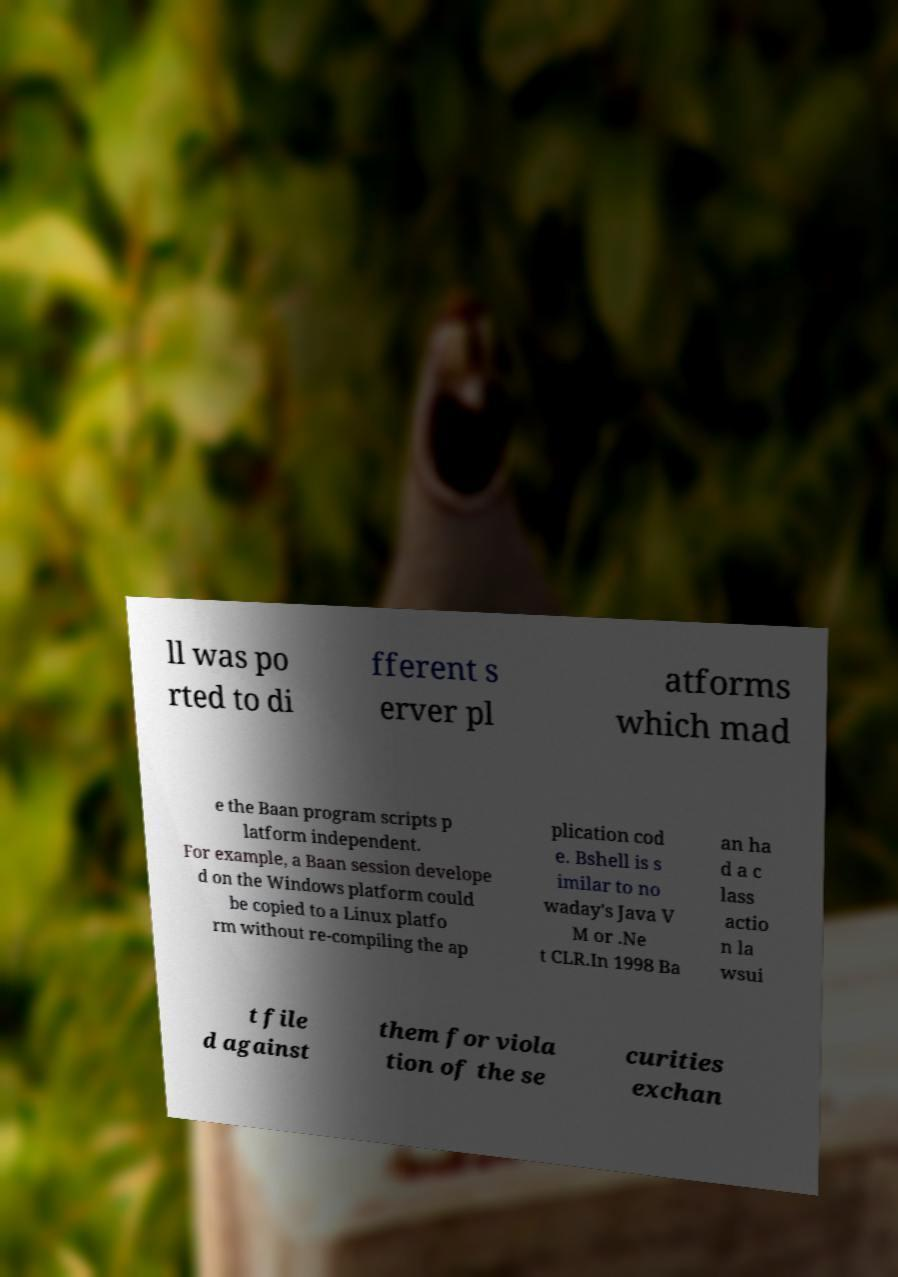There's text embedded in this image that I need extracted. Can you transcribe it verbatim? ll was po rted to di fferent s erver pl atforms which mad e the Baan program scripts p latform independent. For example, a Baan session develope d on the Windows platform could be copied to a Linux platfo rm without re-compiling the ap plication cod e. Bshell is s imilar to no waday's Java V M or .Ne t CLR.In 1998 Ba an ha d a c lass actio n la wsui t file d against them for viola tion of the se curities exchan 